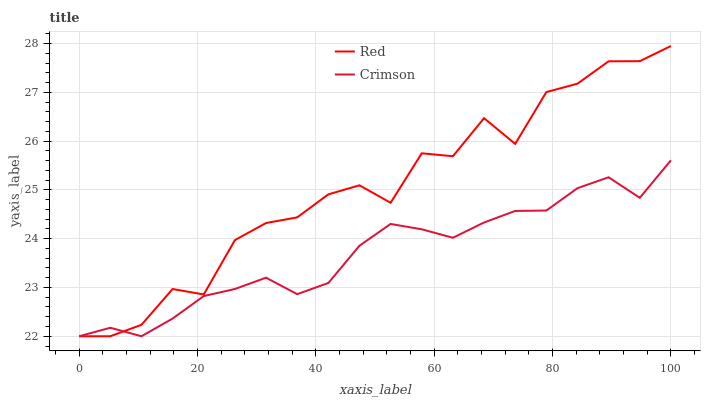Does Crimson have the minimum area under the curve?
Answer yes or no. Yes. Does Red have the maximum area under the curve?
Answer yes or no. Yes. Does Red have the minimum area under the curve?
Answer yes or no. No. Is Crimson the smoothest?
Answer yes or no. Yes. Is Red the roughest?
Answer yes or no. Yes. Is Red the smoothest?
Answer yes or no. No. Does Crimson have the lowest value?
Answer yes or no. Yes. Does Red have the highest value?
Answer yes or no. Yes. Does Crimson intersect Red?
Answer yes or no. Yes. Is Crimson less than Red?
Answer yes or no. No. Is Crimson greater than Red?
Answer yes or no. No. 